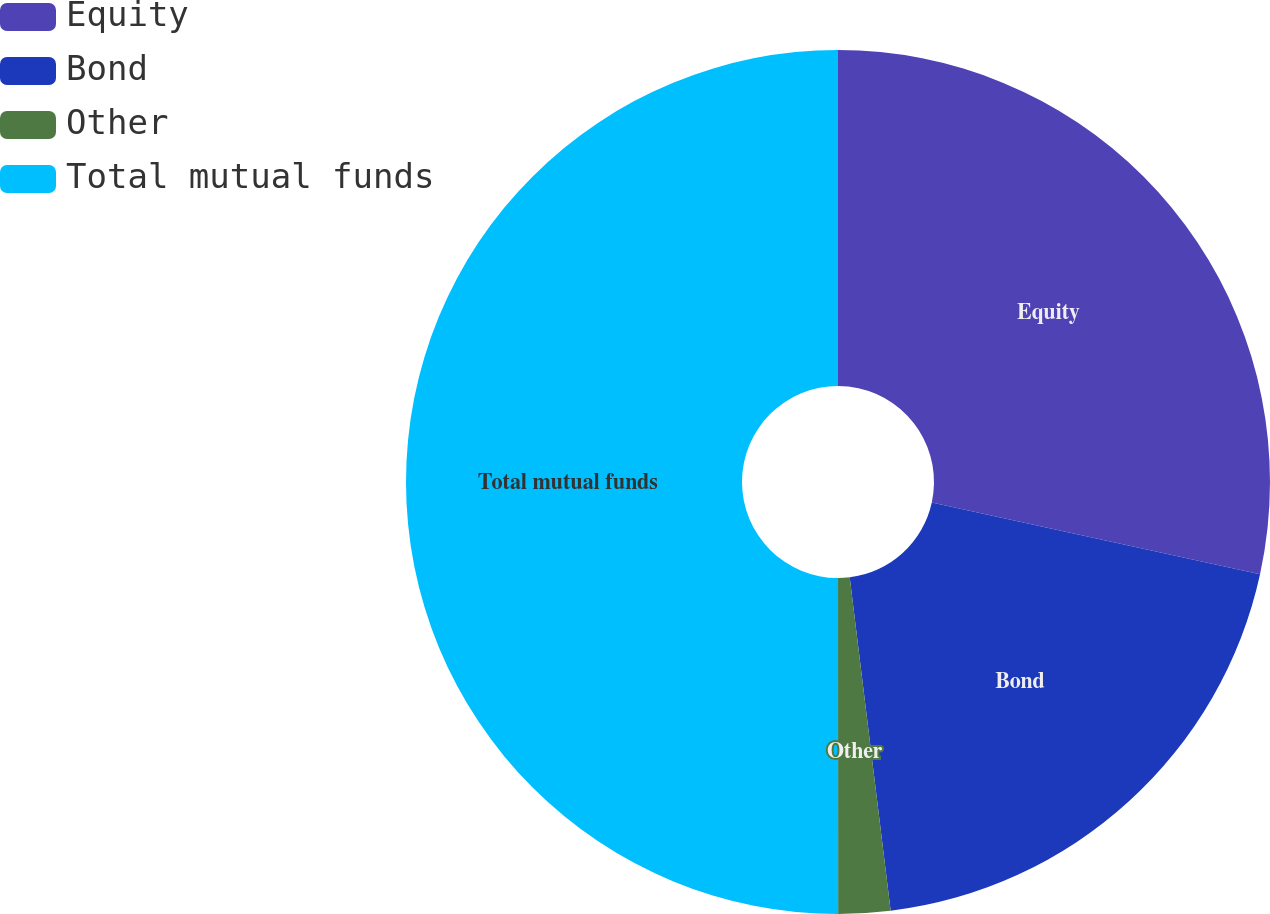Convert chart to OTSL. <chart><loc_0><loc_0><loc_500><loc_500><pie_chart><fcel>Equity<fcel>Bond<fcel>Other<fcel>Total mutual funds<nl><fcel>28.42%<fcel>19.63%<fcel>1.94%<fcel>50.0%<nl></chart> 